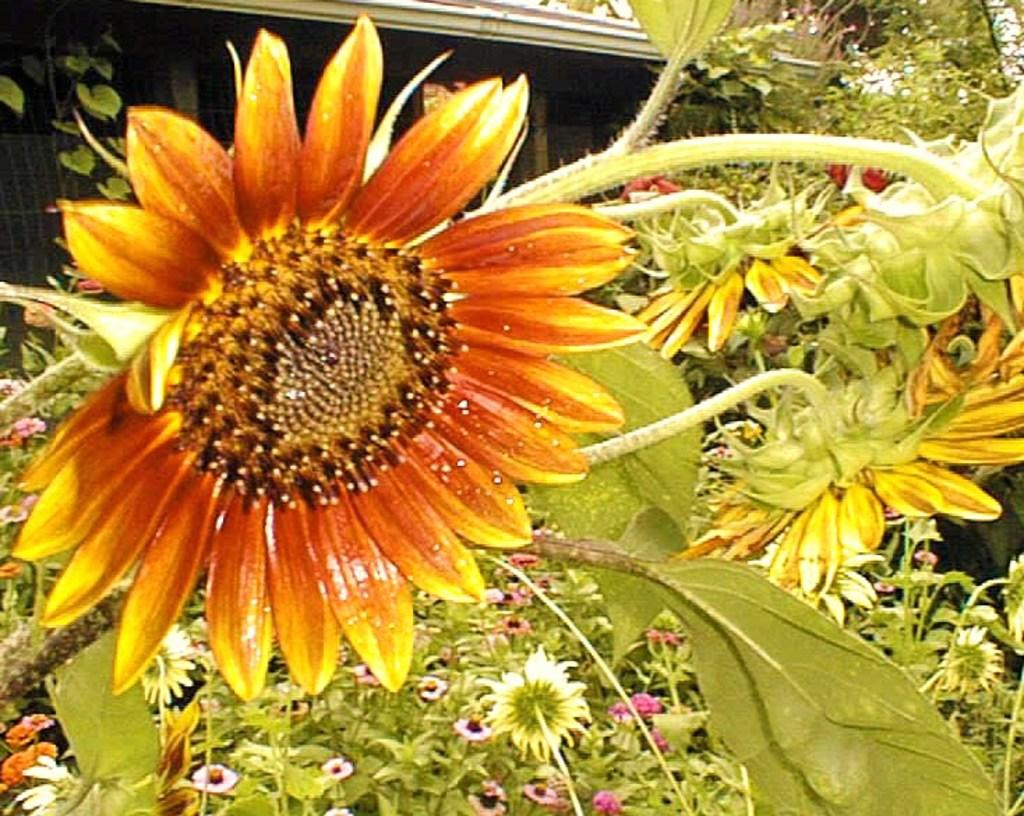What type of plants can be seen in the image? There are flowers in the image. What colors are the flowers? The flowers are in orange and yellow colors. What else can be seen in the image besides the flowers? There are leaves in the image. What color are the leaves? The leaves are green. How much money is being exchanged between the people in the alley in the image? There is no alley or people exchanging money present in the image; it features flowers and leaves. 